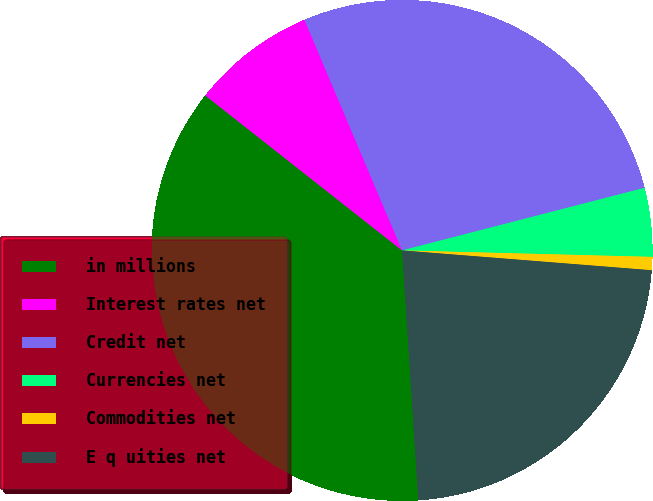<chart> <loc_0><loc_0><loc_500><loc_500><pie_chart><fcel>in millions<fcel>Interest rates net<fcel>Credit net<fcel>Currencies net<fcel>Commodities net<fcel>E q uities net<nl><fcel>36.65%<fcel>8.01%<fcel>27.35%<fcel>4.43%<fcel>0.85%<fcel>22.7%<nl></chart> 